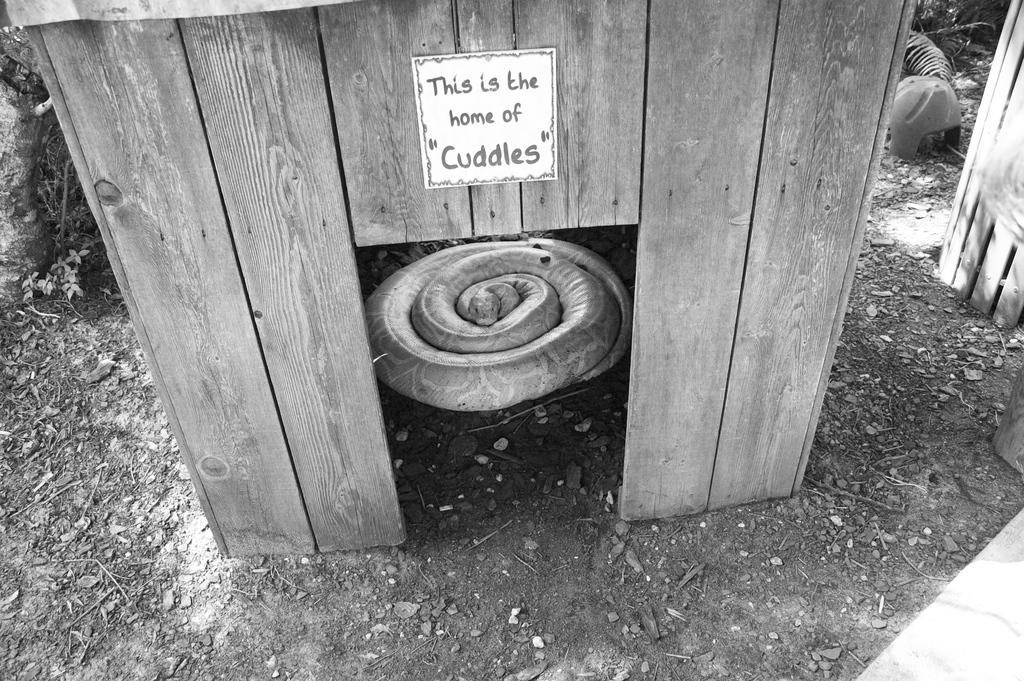What type of structure is in the image? There is a small wooden house in the image. What animal is present in the image? There is a snake in the image. How is the snake positioned in relation to the wooden house? The snake is rolled around the wooden house. What is the condition of the ground around the wooden house? There is a muddy surface around the wooden house. What type of sign can be seen near the wooden house in the image? There is no sign present near the wooden house in the image. How does the sponge help the snake in the image? There is no sponge present in the image, and therefore it cannot help the snake. 